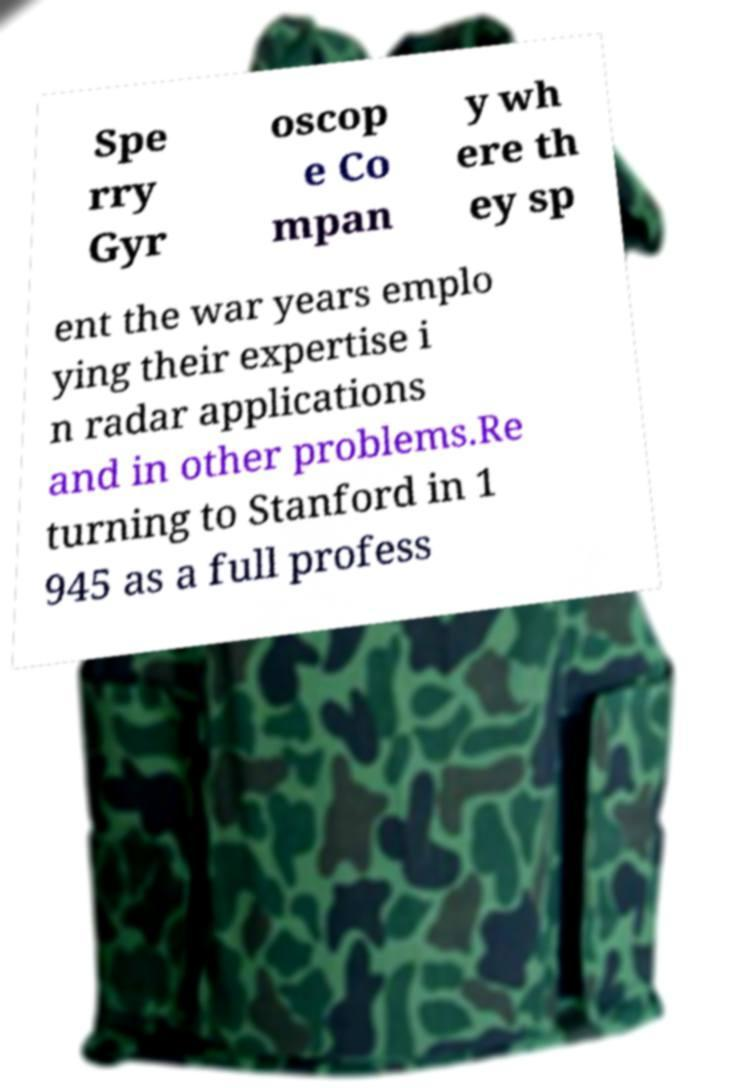I need the written content from this picture converted into text. Can you do that? Spe rry Gyr oscop e Co mpan y wh ere th ey sp ent the war years emplo ying their expertise i n radar applications and in other problems.Re turning to Stanford in 1 945 as a full profess 